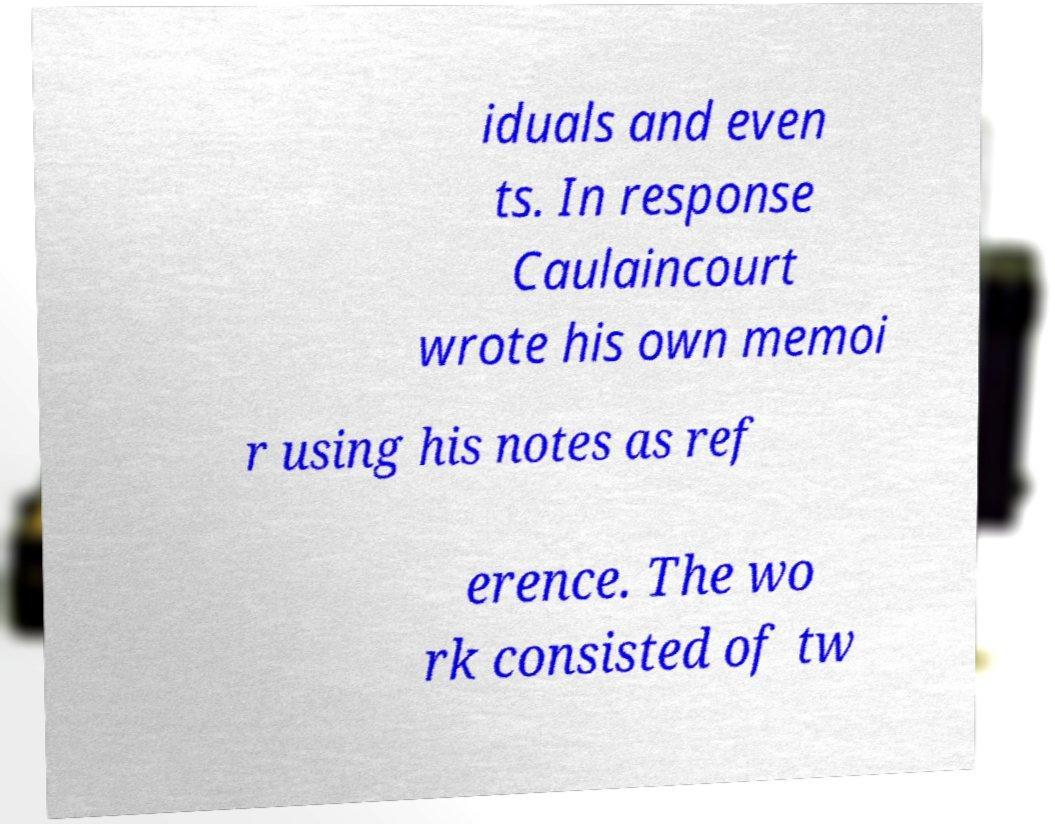Please identify and transcribe the text found in this image. iduals and even ts. In response Caulaincourt wrote his own memoi r using his notes as ref erence. The wo rk consisted of tw 